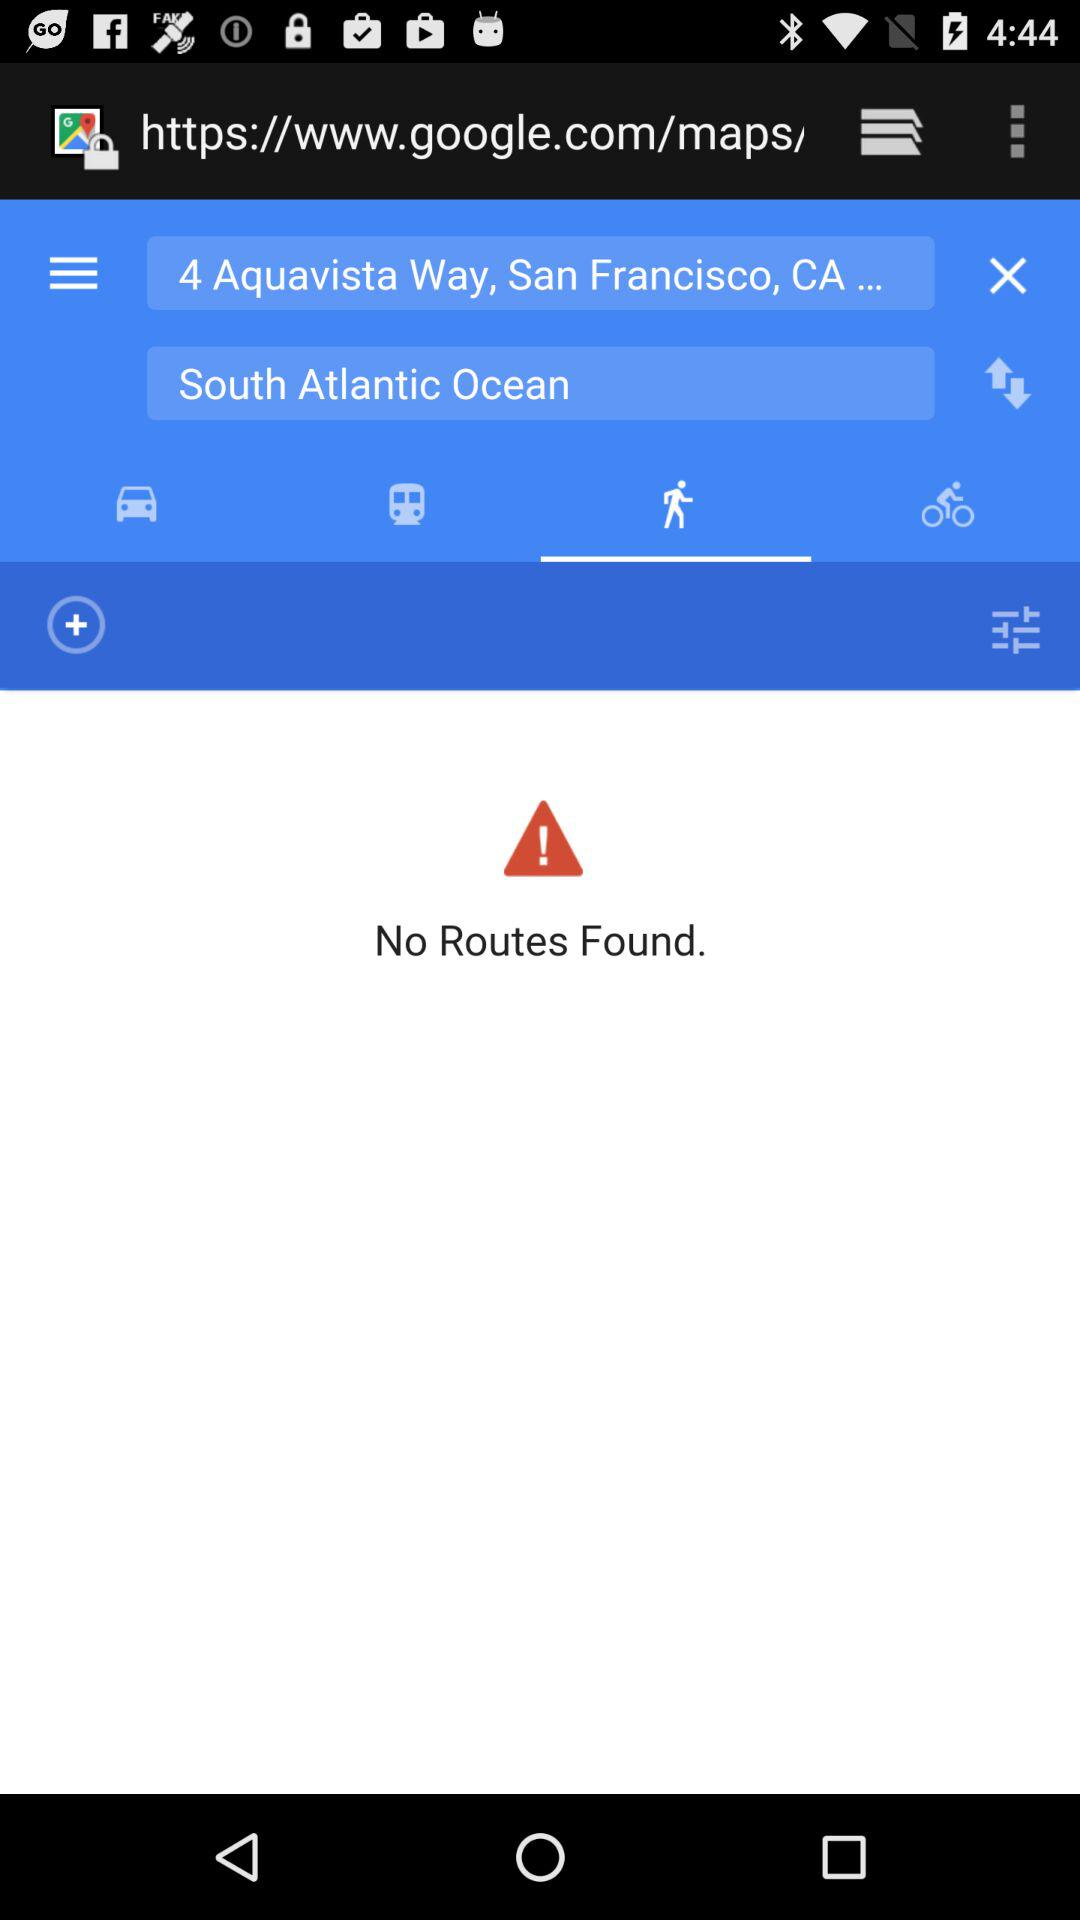What is the input location? The input locations are "4 Aquavista Way, San Francisco, CA..." and the South Atlantic Ocean. 